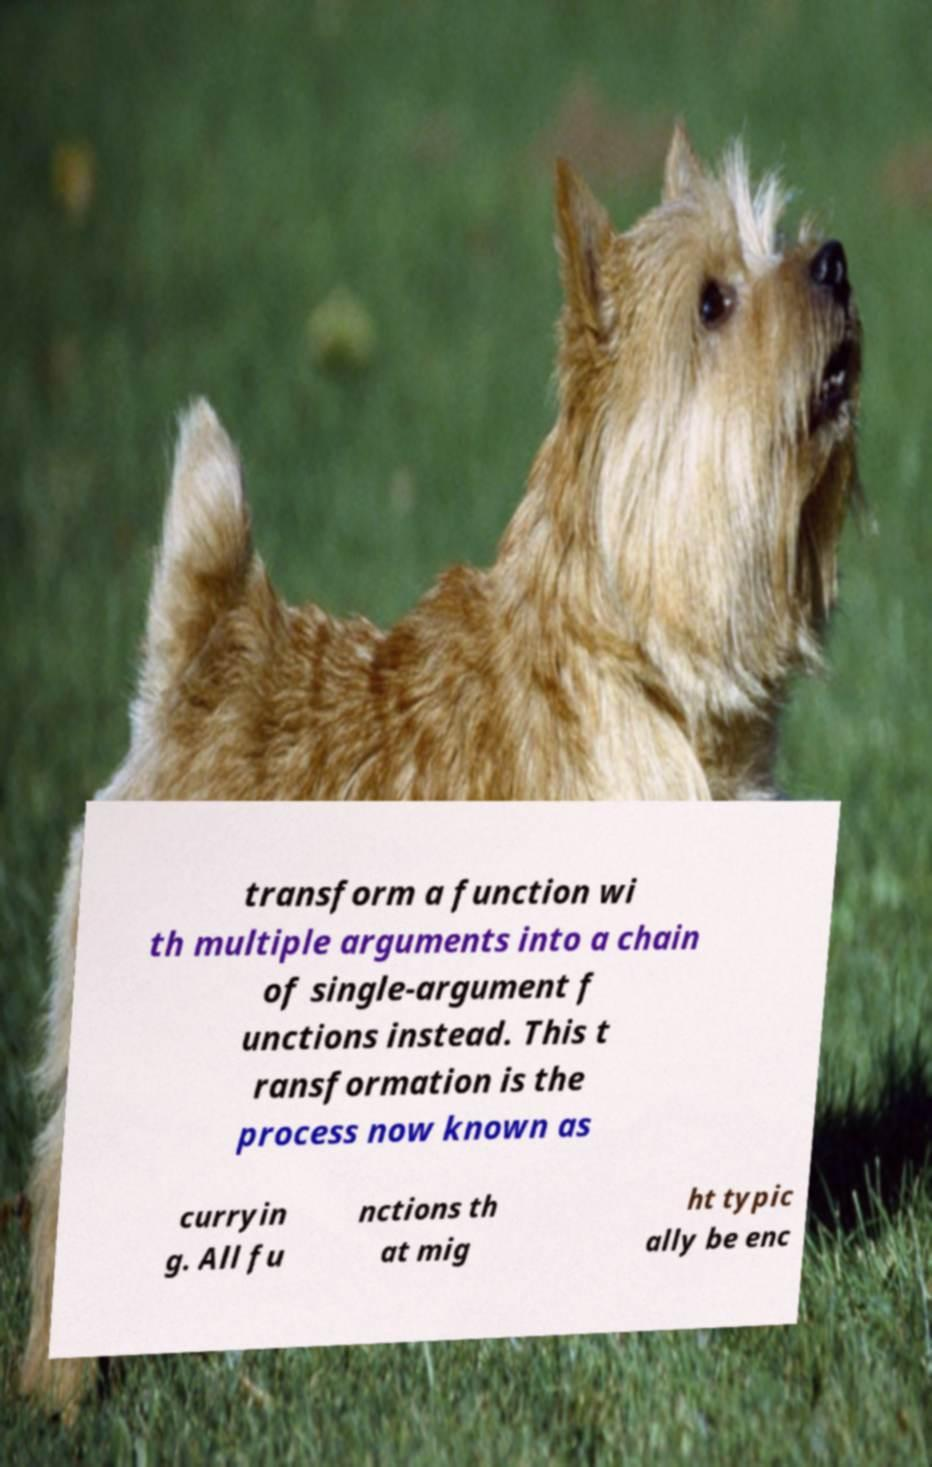Please identify and transcribe the text found in this image. transform a function wi th multiple arguments into a chain of single-argument f unctions instead. This t ransformation is the process now known as curryin g. All fu nctions th at mig ht typic ally be enc 